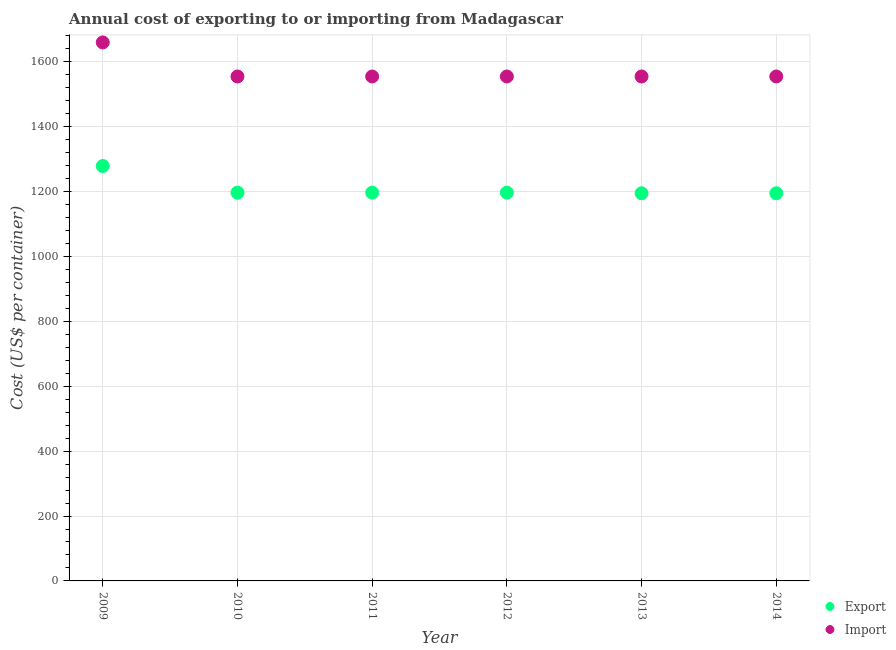How many different coloured dotlines are there?
Offer a very short reply. 2. Is the number of dotlines equal to the number of legend labels?
Make the answer very short. Yes. What is the export cost in 2014?
Your answer should be compact. 1195. Across all years, what is the maximum import cost?
Make the answer very short. 1660. Across all years, what is the minimum export cost?
Give a very brief answer. 1195. In which year was the import cost minimum?
Provide a succinct answer. 2010. What is the total export cost in the graph?
Ensure brevity in your answer.  7260. What is the difference between the export cost in 2009 and that in 2010?
Make the answer very short. 82. What is the difference between the export cost in 2010 and the import cost in 2013?
Make the answer very short. -358. What is the average import cost per year?
Ensure brevity in your answer.  1572.5. In the year 2011, what is the difference between the export cost and import cost?
Give a very brief answer. -358. In how many years, is the import cost greater than 1000 US$?
Keep it short and to the point. 6. What is the ratio of the export cost in 2010 to that in 2012?
Make the answer very short. 1. Is the difference between the export cost in 2011 and 2012 greater than the difference between the import cost in 2011 and 2012?
Your answer should be very brief. No. What is the difference between the highest and the second highest import cost?
Ensure brevity in your answer.  105. What is the difference between the highest and the lowest export cost?
Offer a very short reply. 84. In how many years, is the export cost greater than the average export cost taken over all years?
Provide a short and direct response. 1. Is the import cost strictly less than the export cost over the years?
Give a very brief answer. No. How many years are there in the graph?
Offer a very short reply. 6. What is the difference between two consecutive major ticks on the Y-axis?
Offer a very short reply. 200. Are the values on the major ticks of Y-axis written in scientific E-notation?
Ensure brevity in your answer.  No. Does the graph contain any zero values?
Ensure brevity in your answer.  No. Does the graph contain grids?
Make the answer very short. Yes. How are the legend labels stacked?
Your response must be concise. Vertical. What is the title of the graph?
Ensure brevity in your answer.  Annual cost of exporting to or importing from Madagascar. Does "Arms imports" appear as one of the legend labels in the graph?
Your response must be concise. No. What is the label or title of the X-axis?
Make the answer very short. Year. What is the label or title of the Y-axis?
Offer a terse response. Cost (US$ per container). What is the Cost (US$ per container) in Export in 2009?
Offer a terse response. 1279. What is the Cost (US$ per container) in Import in 2009?
Ensure brevity in your answer.  1660. What is the Cost (US$ per container) in Export in 2010?
Provide a short and direct response. 1197. What is the Cost (US$ per container) of Import in 2010?
Make the answer very short. 1555. What is the Cost (US$ per container) in Export in 2011?
Keep it short and to the point. 1197. What is the Cost (US$ per container) in Import in 2011?
Provide a short and direct response. 1555. What is the Cost (US$ per container) of Export in 2012?
Provide a succinct answer. 1197. What is the Cost (US$ per container) in Import in 2012?
Ensure brevity in your answer.  1555. What is the Cost (US$ per container) of Export in 2013?
Your answer should be compact. 1195. What is the Cost (US$ per container) in Import in 2013?
Your answer should be compact. 1555. What is the Cost (US$ per container) of Export in 2014?
Provide a short and direct response. 1195. What is the Cost (US$ per container) of Import in 2014?
Ensure brevity in your answer.  1555. Across all years, what is the maximum Cost (US$ per container) in Export?
Your answer should be very brief. 1279. Across all years, what is the maximum Cost (US$ per container) in Import?
Your answer should be very brief. 1660. Across all years, what is the minimum Cost (US$ per container) of Export?
Keep it short and to the point. 1195. Across all years, what is the minimum Cost (US$ per container) of Import?
Your response must be concise. 1555. What is the total Cost (US$ per container) of Export in the graph?
Offer a terse response. 7260. What is the total Cost (US$ per container) in Import in the graph?
Ensure brevity in your answer.  9435. What is the difference between the Cost (US$ per container) in Export in 2009 and that in 2010?
Your answer should be compact. 82. What is the difference between the Cost (US$ per container) of Import in 2009 and that in 2010?
Offer a very short reply. 105. What is the difference between the Cost (US$ per container) in Import in 2009 and that in 2011?
Offer a terse response. 105. What is the difference between the Cost (US$ per container) of Import in 2009 and that in 2012?
Give a very brief answer. 105. What is the difference between the Cost (US$ per container) of Import in 2009 and that in 2013?
Offer a terse response. 105. What is the difference between the Cost (US$ per container) in Export in 2009 and that in 2014?
Your answer should be very brief. 84. What is the difference between the Cost (US$ per container) in Import in 2009 and that in 2014?
Ensure brevity in your answer.  105. What is the difference between the Cost (US$ per container) in Import in 2010 and that in 2011?
Give a very brief answer. 0. What is the difference between the Cost (US$ per container) in Export in 2010 and that in 2012?
Provide a short and direct response. 0. What is the difference between the Cost (US$ per container) of Export in 2010 and that in 2013?
Offer a terse response. 2. What is the difference between the Cost (US$ per container) of Export in 2011 and that in 2012?
Provide a short and direct response. 0. What is the difference between the Cost (US$ per container) of Import in 2011 and that in 2012?
Offer a very short reply. 0. What is the difference between the Cost (US$ per container) of Export in 2011 and that in 2013?
Keep it short and to the point. 2. What is the difference between the Cost (US$ per container) of Export in 2011 and that in 2014?
Provide a succinct answer. 2. What is the difference between the Cost (US$ per container) of Import in 2011 and that in 2014?
Offer a very short reply. 0. What is the difference between the Cost (US$ per container) of Export in 2012 and that in 2014?
Give a very brief answer. 2. What is the difference between the Cost (US$ per container) in Import in 2012 and that in 2014?
Your answer should be compact. 0. What is the difference between the Cost (US$ per container) of Export in 2013 and that in 2014?
Your response must be concise. 0. What is the difference between the Cost (US$ per container) in Export in 2009 and the Cost (US$ per container) in Import in 2010?
Provide a succinct answer. -276. What is the difference between the Cost (US$ per container) of Export in 2009 and the Cost (US$ per container) of Import in 2011?
Provide a short and direct response. -276. What is the difference between the Cost (US$ per container) of Export in 2009 and the Cost (US$ per container) of Import in 2012?
Provide a short and direct response. -276. What is the difference between the Cost (US$ per container) in Export in 2009 and the Cost (US$ per container) in Import in 2013?
Offer a terse response. -276. What is the difference between the Cost (US$ per container) in Export in 2009 and the Cost (US$ per container) in Import in 2014?
Keep it short and to the point. -276. What is the difference between the Cost (US$ per container) of Export in 2010 and the Cost (US$ per container) of Import in 2011?
Your answer should be very brief. -358. What is the difference between the Cost (US$ per container) in Export in 2010 and the Cost (US$ per container) in Import in 2012?
Make the answer very short. -358. What is the difference between the Cost (US$ per container) of Export in 2010 and the Cost (US$ per container) of Import in 2013?
Offer a terse response. -358. What is the difference between the Cost (US$ per container) in Export in 2010 and the Cost (US$ per container) in Import in 2014?
Your answer should be compact. -358. What is the difference between the Cost (US$ per container) in Export in 2011 and the Cost (US$ per container) in Import in 2012?
Give a very brief answer. -358. What is the difference between the Cost (US$ per container) of Export in 2011 and the Cost (US$ per container) of Import in 2013?
Your answer should be very brief. -358. What is the difference between the Cost (US$ per container) in Export in 2011 and the Cost (US$ per container) in Import in 2014?
Make the answer very short. -358. What is the difference between the Cost (US$ per container) in Export in 2012 and the Cost (US$ per container) in Import in 2013?
Keep it short and to the point. -358. What is the difference between the Cost (US$ per container) of Export in 2012 and the Cost (US$ per container) of Import in 2014?
Offer a very short reply. -358. What is the difference between the Cost (US$ per container) in Export in 2013 and the Cost (US$ per container) in Import in 2014?
Provide a succinct answer. -360. What is the average Cost (US$ per container) of Export per year?
Provide a short and direct response. 1210. What is the average Cost (US$ per container) in Import per year?
Provide a short and direct response. 1572.5. In the year 2009, what is the difference between the Cost (US$ per container) of Export and Cost (US$ per container) of Import?
Offer a very short reply. -381. In the year 2010, what is the difference between the Cost (US$ per container) of Export and Cost (US$ per container) of Import?
Offer a terse response. -358. In the year 2011, what is the difference between the Cost (US$ per container) of Export and Cost (US$ per container) of Import?
Your response must be concise. -358. In the year 2012, what is the difference between the Cost (US$ per container) of Export and Cost (US$ per container) of Import?
Your response must be concise. -358. In the year 2013, what is the difference between the Cost (US$ per container) of Export and Cost (US$ per container) of Import?
Offer a very short reply. -360. In the year 2014, what is the difference between the Cost (US$ per container) of Export and Cost (US$ per container) of Import?
Your response must be concise. -360. What is the ratio of the Cost (US$ per container) in Export in 2009 to that in 2010?
Provide a short and direct response. 1.07. What is the ratio of the Cost (US$ per container) in Import in 2009 to that in 2010?
Your answer should be very brief. 1.07. What is the ratio of the Cost (US$ per container) in Export in 2009 to that in 2011?
Provide a succinct answer. 1.07. What is the ratio of the Cost (US$ per container) in Import in 2009 to that in 2011?
Make the answer very short. 1.07. What is the ratio of the Cost (US$ per container) of Export in 2009 to that in 2012?
Provide a succinct answer. 1.07. What is the ratio of the Cost (US$ per container) of Import in 2009 to that in 2012?
Provide a short and direct response. 1.07. What is the ratio of the Cost (US$ per container) in Export in 2009 to that in 2013?
Offer a terse response. 1.07. What is the ratio of the Cost (US$ per container) of Import in 2009 to that in 2013?
Your response must be concise. 1.07. What is the ratio of the Cost (US$ per container) in Export in 2009 to that in 2014?
Provide a succinct answer. 1.07. What is the ratio of the Cost (US$ per container) in Import in 2009 to that in 2014?
Provide a short and direct response. 1.07. What is the ratio of the Cost (US$ per container) in Export in 2010 to that in 2012?
Your answer should be very brief. 1. What is the ratio of the Cost (US$ per container) of Export in 2010 to that in 2013?
Offer a very short reply. 1. What is the ratio of the Cost (US$ per container) in Import in 2010 to that in 2013?
Provide a short and direct response. 1. What is the ratio of the Cost (US$ per container) of Export in 2010 to that in 2014?
Provide a short and direct response. 1. What is the ratio of the Cost (US$ per container) in Import in 2010 to that in 2014?
Provide a short and direct response. 1. What is the ratio of the Cost (US$ per container) in Export in 2011 to that in 2012?
Your response must be concise. 1. What is the ratio of the Cost (US$ per container) in Export in 2011 to that in 2013?
Your answer should be very brief. 1. What is the ratio of the Cost (US$ per container) of Import in 2011 to that in 2014?
Ensure brevity in your answer.  1. What is the ratio of the Cost (US$ per container) of Export in 2013 to that in 2014?
Your answer should be compact. 1. What is the ratio of the Cost (US$ per container) of Import in 2013 to that in 2014?
Keep it short and to the point. 1. What is the difference between the highest and the second highest Cost (US$ per container) of Export?
Provide a succinct answer. 82. What is the difference between the highest and the second highest Cost (US$ per container) of Import?
Give a very brief answer. 105. What is the difference between the highest and the lowest Cost (US$ per container) in Export?
Give a very brief answer. 84. What is the difference between the highest and the lowest Cost (US$ per container) of Import?
Offer a terse response. 105. 